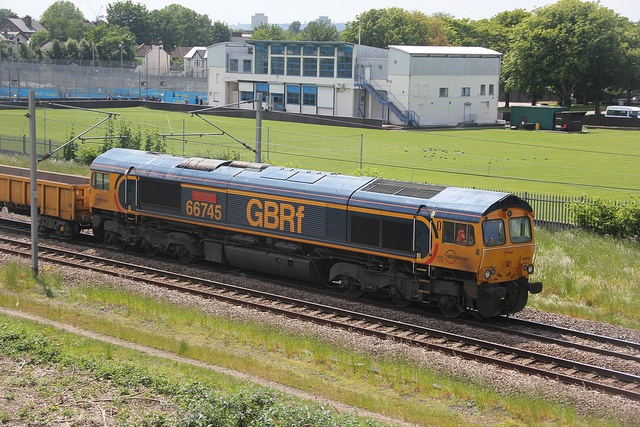Describe the objects in this image and their specific colors. I can see train in white, black, brown, gray, and lightgray tones, car in white, lightgray, gray, black, and darkgray tones, truck in white, lightgray, gray, black, and darkgray tones, people in white, maroon, black, gray, and brown tones, and people in white and gray tones in this image. 